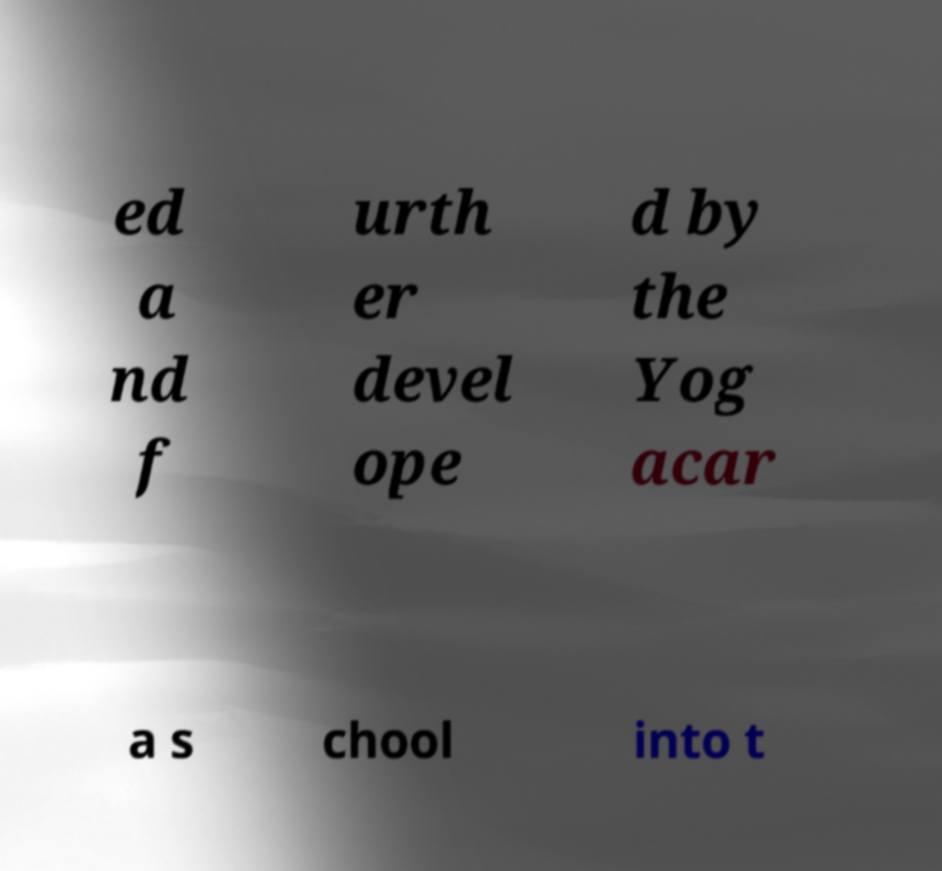For documentation purposes, I need the text within this image transcribed. Could you provide that? ed a nd f urth er devel ope d by the Yog acar a s chool into t 